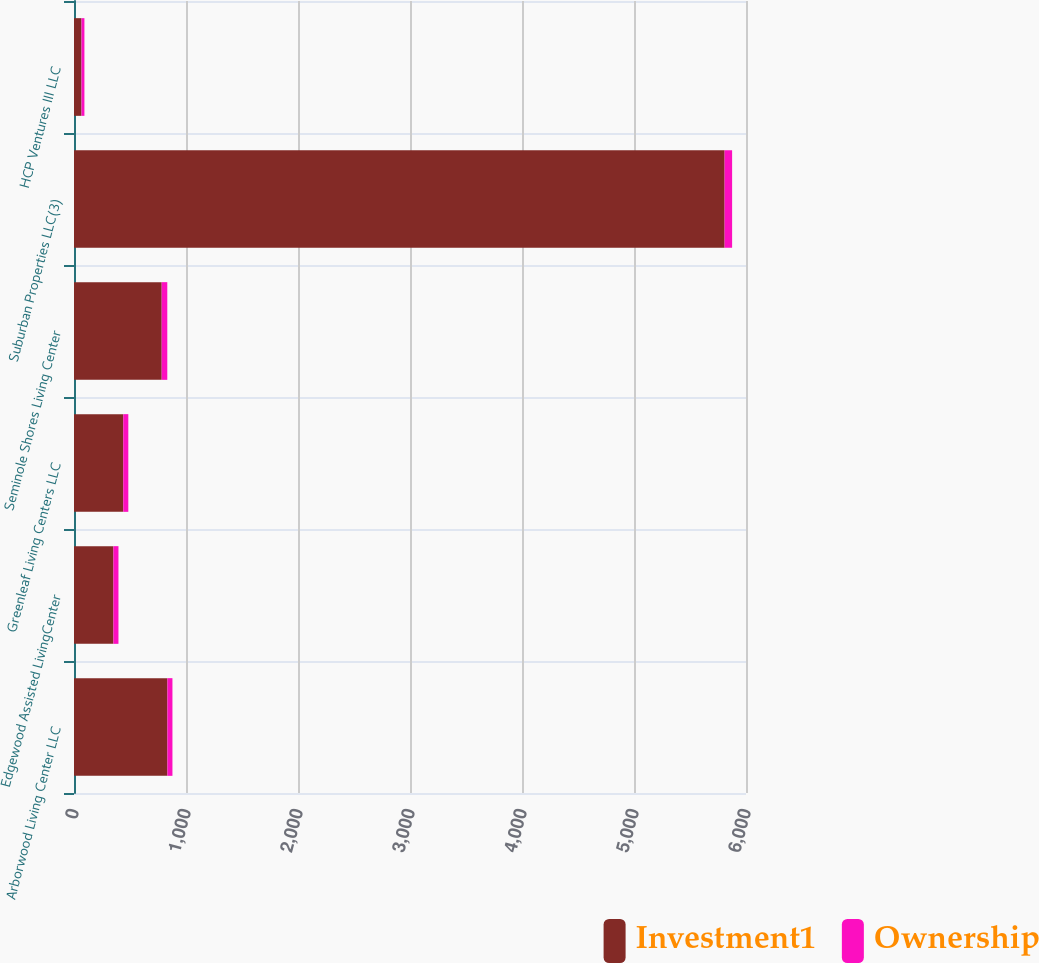Convert chart. <chart><loc_0><loc_0><loc_500><loc_500><stacked_bar_chart><ecel><fcel>Arborwood Living Center LLC<fcel>Edgewood Assisted LivingCenter<fcel>Greenleaf Living Centers LLC<fcel>Seminole Shores Living Center<fcel>Suburban Properties LLC(3)<fcel>HCP Ventures III LLC<nl><fcel>Investment1<fcel>834<fcel>352<fcel>440<fcel>783<fcel>5809<fcel>67<nl><fcel>Ownership<fcel>45<fcel>45<fcel>45<fcel>50<fcel>67<fcel>26<nl></chart> 